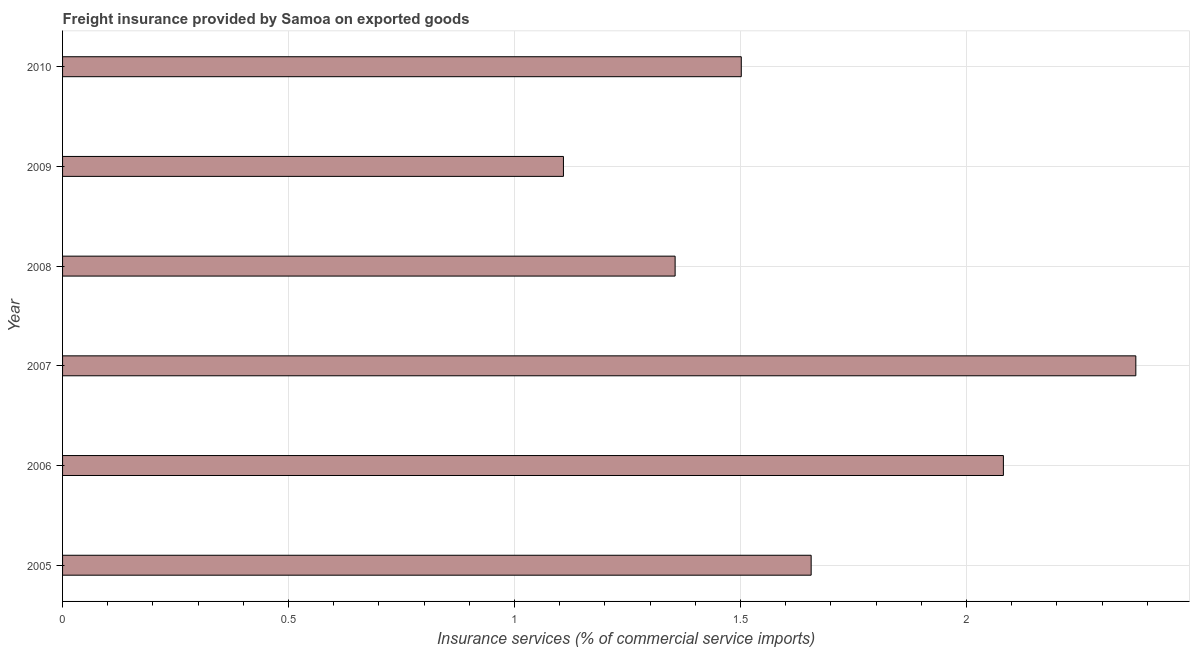Does the graph contain grids?
Offer a very short reply. Yes. What is the title of the graph?
Give a very brief answer. Freight insurance provided by Samoa on exported goods . What is the label or title of the X-axis?
Your answer should be very brief. Insurance services (% of commercial service imports). What is the label or title of the Y-axis?
Your response must be concise. Year. What is the freight insurance in 2007?
Your answer should be very brief. 2.37. Across all years, what is the maximum freight insurance?
Ensure brevity in your answer.  2.37. Across all years, what is the minimum freight insurance?
Give a very brief answer. 1.11. What is the sum of the freight insurance?
Keep it short and to the point. 10.08. What is the difference between the freight insurance in 2005 and 2007?
Provide a succinct answer. -0.72. What is the average freight insurance per year?
Offer a terse response. 1.68. What is the median freight insurance?
Offer a terse response. 1.58. Do a majority of the years between 2009 and 2005 (inclusive) have freight insurance greater than 0.7 %?
Offer a very short reply. Yes. What is the ratio of the freight insurance in 2005 to that in 2009?
Give a very brief answer. 1.5. Is the difference between the freight insurance in 2005 and 2009 greater than the difference between any two years?
Your answer should be very brief. No. What is the difference between the highest and the second highest freight insurance?
Your response must be concise. 0.29. What is the difference between the highest and the lowest freight insurance?
Your response must be concise. 1.27. How many bars are there?
Your response must be concise. 6. Are all the bars in the graph horizontal?
Provide a short and direct response. Yes. What is the difference between two consecutive major ticks on the X-axis?
Your response must be concise. 0.5. What is the Insurance services (% of commercial service imports) of 2005?
Your answer should be compact. 1.66. What is the Insurance services (% of commercial service imports) of 2006?
Keep it short and to the point. 2.08. What is the Insurance services (% of commercial service imports) in 2007?
Make the answer very short. 2.37. What is the Insurance services (% of commercial service imports) of 2008?
Your response must be concise. 1.36. What is the Insurance services (% of commercial service imports) of 2009?
Your answer should be very brief. 1.11. What is the Insurance services (% of commercial service imports) in 2010?
Ensure brevity in your answer.  1.5. What is the difference between the Insurance services (% of commercial service imports) in 2005 and 2006?
Offer a terse response. -0.43. What is the difference between the Insurance services (% of commercial service imports) in 2005 and 2007?
Offer a terse response. -0.72. What is the difference between the Insurance services (% of commercial service imports) in 2005 and 2008?
Offer a very short reply. 0.3. What is the difference between the Insurance services (% of commercial service imports) in 2005 and 2009?
Provide a succinct answer. 0.55. What is the difference between the Insurance services (% of commercial service imports) in 2005 and 2010?
Ensure brevity in your answer.  0.15. What is the difference between the Insurance services (% of commercial service imports) in 2006 and 2007?
Give a very brief answer. -0.29. What is the difference between the Insurance services (% of commercial service imports) in 2006 and 2008?
Ensure brevity in your answer.  0.73. What is the difference between the Insurance services (% of commercial service imports) in 2006 and 2009?
Your answer should be very brief. 0.97. What is the difference between the Insurance services (% of commercial service imports) in 2006 and 2010?
Provide a short and direct response. 0.58. What is the difference between the Insurance services (% of commercial service imports) in 2007 and 2008?
Ensure brevity in your answer.  1.02. What is the difference between the Insurance services (% of commercial service imports) in 2007 and 2009?
Offer a terse response. 1.27. What is the difference between the Insurance services (% of commercial service imports) in 2007 and 2010?
Give a very brief answer. 0.87. What is the difference between the Insurance services (% of commercial service imports) in 2008 and 2009?
Make the answer very short. 0.25. What is the difference between the Insurance services (% of commercial service imports) in 2008 and 2010?
Offer a very short reply. -0.15. What is the difference between the Insurance services (% of commercial service imports) in 2009 and 2010?
Your response must be concise. -0.39. What is the ratio of the Insurance services (% of commercial service imports) in 2005 to that in 2006?
Provide a succinct answer. 0.8. What is the ratio of the Insurance services (% of commercial service imports) in 2005 to that in 2007?
Offer a very short reply. 0.7. What is the ratio of the Insurance services (% of commercial service imports) in 2005 to that in 2008?
Ensure brevity in your answer.  1.22. What is the ratio of the Insurance services (% of commercial service imports) in 2005 to that in 2009?
Ensure brevity in your answer.  1.5. What is the ratio of the Insurance services (% of commercial service imports) in 2005 to that in 2010?
Provide a succinct answer. 1.1. What is the ratio of the Insurance services (% of commercial service imports) in 2006 to that in 2007?
Offer a very short reply. 0.88. What is the ratio of the Insurance services (% of commercial service imports) in 2006 to that in 2008?
Your response must be concise. 1.54. What is the ratio of the Insurance services (% of commercial service imports) in 2006 to that in 2009?
Give a very brief answer. 1.88. What is the ratio of the Insurance services (% of commercial service imports) in 2006 to that in 2010?
Make the answer very short. 1.39. What is the ratio of the Insurance services (% of commercial service imports) in 2007 to that in 2008?
Provide a succinct answer. 1.75. What is the ratio of the Insurance services (% of commercial service imports) in 2007 to that in 2009?
Ensure brevity in your answer.  2.14. What is the ratio of the Insurance services (% of commercial service imports) in 2007 to that in 2010?
Ensure brevity in your answer.  1.58. What is the ratio of the Insurance services (% of commercial service imports) in 2008 to that in 2009?
Your answer should be compact. 1.22. What is the ratio of the Insurance services (% of commercial service imports) in 2008 to that in 2010?
Provide a succinct answer. 0.9. What is the ratio of the Insurance services (% of commercial service imports) in 2009 to that in 2010?
Your answer should be very brief. 0.74. 